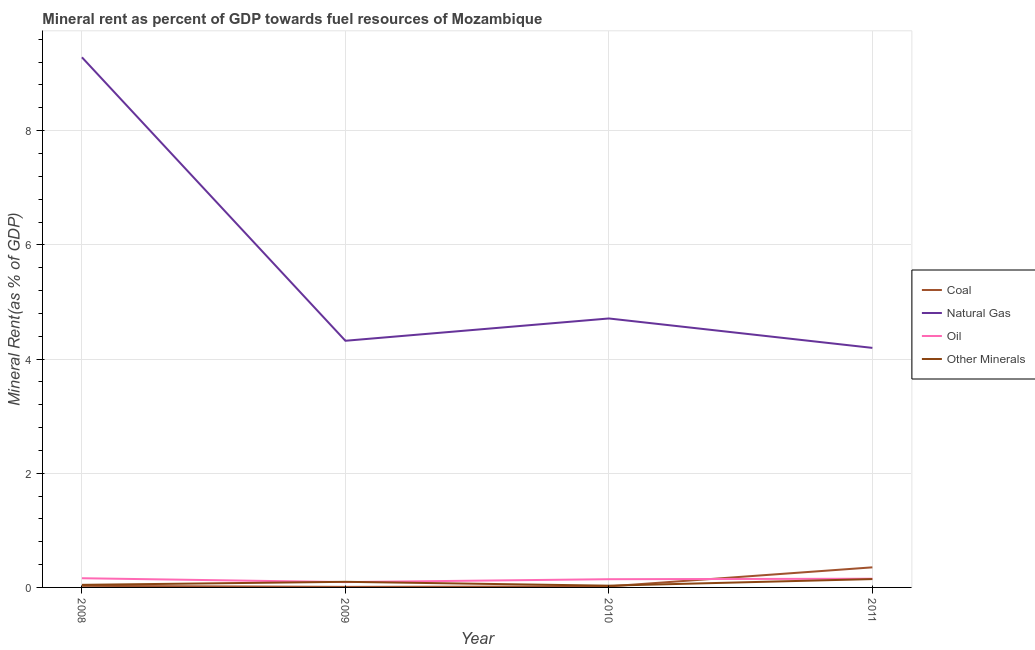Is the number of lines equal to the number of legend labels?
Ensure brevity in your answer.  Yes. What is the natural gas rent in 2011?
Keep it short and to the point. 4.2. Across all years, what is the maximum coal rent?
Ensure brevity in your answer.  0.35. Across all years, what is the minimum natural gas rent?
Offer a terse response. 4.2. What is the total coal rent in the graph?
Your answer should be very brief. 0.41. What is the difference between the  rent of other minerals in 2009 and that in 2010?
Make the answer very short. 0.07. What is the difference between the oil rent in 2009 and the natural gas rent in 2010?
Offer a very short reply. -4.62. What is the average oil rent per year?
Offer a terse response. 0.14. In the year 2009, what is the difference between the oil rent and natural gas rent?
Offer a very short reply. -4.23. In how many years, is the natural gas rent greater than 0.4 %?
Offer a terse response. 4. What is the ratio of the coal rent in 2008 to that in 2009?
Make the answer very short. 2.88. Is the difference between the natural gas rent in 2010 and 2011 greater than the difference between the  rent of other minerals in 2010 and 2011?
Provide a succinct answer. Yes. What is the difference between the highest and the second highest oil rent?
Provide a succinct answer. 0.01. What is the difference between the highest and the lowest  rent of other minerals?
Provide a succinct answer. 0.12. Is it the case that in every year, the sum of the natural gas rent and coal rent is greater than the sum of oil rent and  rent of other minerals?
Your answer should be very brief. Yes. Is the coal rent strictly greater than the natural gas rent over the years?
Your answer should be compact. No. Is the oil rent strictly less than the natural gas rent over the years?
Your answer should be compact. Yes. How many lines are there?
Provide a short and direct response. 4. What is the difference between two consecutive major ticks on the Y-axis?
Give a very brief answer. 2. Does the graph contain any zero values?
Provide a short and direct response. No. Where does the legend appear in the graph?
Give a very brief answer. Center right. How many legend labels are there?
Make the answer very short. 4. How are the legend labels stacked?
Your response must be concise. Vertical. What is the title of the graph?
Your answer should be compact. Mineral rent as percent of GDP towards fuel resources of Mozambique. Does "Insurance services" appear as one of the legend labels in the graph?
Keep it short and to the point. No. What is the label or title of the Y-axis?
Offer a terse response. Mineral Rent(as % of GDP). What is the Mineral Rent(as % of GDP) of Coal in 2008?
Ensure brevity in your answer.  0.03. What is the Mineral Rent(as % of GDP) in Natural Gas in 2008?
Keep it short and to the point. 9.29. What is the Mineral Rent(as % of GDP) in Oil in 2008?
Provide a succinct answer. 0.16. What is the Mineral Rent(as % of GDP) in Other Minerals in 2008?
Provide a succinct answer. 0.05. What is the Mineral Rent(as % of GDP) in Coal in 2009?
Ensure brevity in your answer.  0.01. What is the Mineral Rent(as % of GDP) of Natural Gas in 2009?
Offer a terse response. 4.32. What is the Mineral Rent(as % of GDP) of Oil in 2009?
Give a very brief answer. 0.09. What is the Mineral Rent(as % of GDP) in Other Minerals in 2009?
Your answer should be compact. 0.1. What is the Mineral Rent(as % of GDP) in Coal in 2010?
Keep it short and to the point. 0.02. What is the Mineral Rent(as % of GDP) in Natural Gas in 2010?
Offer a very short reply. 4.71. What is the Mineral Rent(as % of GDP) in Oil in 2010?
Ensure brevity in your answer.  0.14. What is the Mineral Rent(as % of GDP) of Other Minerals in 2010?
Provide a short and direct response. 0.03. What is the Mineral Rent(as % of GDP) in Coal in 2011?
Provide a succinct answer. 0.35. What is the Mineral Rent(as % of GDP) of Natural Gas in 2011?
Ensure brevity in your answer.  4.2. What is the Mineral Rent(as % of GDP) of Oil in 2011?
Your answer should be very brief. 0.15. What is the Mineral Rent(as % of GDP) of Other Minerals in 2011?
Give a very brief answer. 0.15. Across all years, what is the maximum Mineral Rent(as % of GDP) in Coal?
Provide a short and direct response. 0.35. Across all years, what is the maximum Mineral Rent(as % of GDP) of Natural Gas?
Your response must be concise. 9.29. Across all years, what is the maximum Mineral Rent(as % of GDP) in Oil?
Make the answer very short. 0.16. Across all years, what is the maximum Mineral Rent(as % of GDP) in Other Minerals?
Make the answer very short. 0.15. Across all years, what is the minimum Mineral Rent(as % of GDP) of Coal?
Offer a terse response. 0.01. Across all years, what is the minimum Mineral Rent(as % of GDP) in Natural Gas?
Give a very brief answer. 4.2. Across all years, what is the minimum Mineral Rent(as % of GDP) of Oil?
Provide a succinct answer. 0.09. Across all years, what is the minimum Mineral Rent(as % of GDP) of Other Minerals?
Offer a very short reply. 0.03. What is the total Mineral Rent(as % of GDP) of Coal in the graph?
Offer a very short reply. 0.41. What is the total Mineral Rent(as % of GDP) in Natural Gas in the graph?
Offer a very short reply. 22.51. What is the total Mineral Rent(as % of GDP) of Oil in the graph?
Your response must be concise. 0.55. What is the total Mineral Rent(as % of GDP) of Other Minerals in the graph?
Provide a short and direct response. 0.32. What is the difference between the Mineral Rent(as % of GDP) in Coal in 2008 and that in 2009?
Your answer should be very brief. 0.02. What is the difference between the Mineral Rent(as % of GDP) in Natural Gas in 2008 and that in 2009?
Provide a succinct answer. 4.96. What is the difference between the Mineral Rent(as % of GDP) of Oil in 2008 and that in 2009?
Provide a succinct answer. 0.07. What is the difference between the Mineral Rent(as % of GDP) of Other Minerals in 2008 and that in 2009?
Offer a terse response. -0.05. What is the difference between the Mineral Rent(as % of GDP) of Coal in 2008 and that in 2010?
Make the answer very short. 0.01. What is the difference between the Mineral Rent(as % of GDP) of Natural Gas in 2008 and that in 2010?
Your answer should be very brief. 4.57. What is the difference between the Mineral Rent(as % of GDP) in Oil in 2008 and that in 2010?
Your answer should be very brief. 0.02. What is the difference between the Mineral Rent(as % of GDP) in Other Minerals in 2008 and that in 2010?
Offer a very short reply. 0.01. What is the difference between the Mineral Rent(as % of GDP) of Coal in 2008 and that in 2011?
Your response must be concise. -0.32. What is the difference between the Mineral Rent(as % of GDP) in Natural Gas in 2008 and that in 2011?
Offer a terse response. 5.09. What is the difference between the Mineral Rent(as % of GDP) in Oil in 2008 and that in 2011?
Your answer should be compact. 0.01. What is the difference between the Mineral Rent(as % of GDP) of Other Minerals in 2008 and that in 2011?
Make the answer very short. -0.1. What is the difference between the Mineral Rent(as % of GDP) of Coal in 2009 and that in 2010?
Your answer should be compact. -0.01. What is the difference between the Mineral Rent(as % of GDP) in Natural Gas in 2009 and that in 2010?
Give a very brief answer. -0.39. What is the difference between the Mineral Rent(as % of GDP) of Oil in 2009 and that in 2010?
Offer a very short reply. -0.05. What is the difference between the Mineral Rent(as % of GDP) in Other Minerals in 2009 and that in 2010?
Offer a very short reply. 0.07. What is the difference between the Mineral Rent(as % of GDP) in Coal in 2009 and that in 2011?
Your answer should be very brief. -0.34. What is the difference between the Mineral Rent(as % of GDP) of Natural Gas in 2009 and that in 2011?
Give a very brief answer. 0.12. What is the difference between the Mineral Rent(as % of GDP) in Oil in 2009 and that in 2011?
Give a very brief answer. -0.06. What is the difference between the Mineral Rent(as % of GDP) of Other Minerals in 2009 and that in 2011?
Your answer should be very brief. -0.05. What is the difference between the Mineral Rent(as % of GDP) of Coal in 2010 and that in 2011?
Give a very brief answer. -0.33. What is the difference between the Mineral Rent(as % of GDP) of Natural Gas in 2010 and that in 2011?
Your answer should be very brief. 0.52. What is the difference between the Mineral Rent(as % of GDP) in Oil in 2010 and that in 2011?
Your answer should be very brief. -0.01. What is the difference between the Mineral Rent(as % of GDP) of Other Minerals in 2010 and that in 2011?
Make the answer very short. -0.12. What is the difference between the Mineral Rent(as % of GDP) in Coal in 2008 and the Mineral Rent(as % of GDP) in Natural Gas in 2009?
Offer a very short reply. -4.29. What is the difference between the Mineral Rent(as % of GDP) in Coal in 2008 and the Mineral Rent(as % of GDP) in Oil in 2009?
Your answer should be compact. -0.07. What is the difference between the Mineral Rent(as % of GDP) of Coal in 2008 and the Mineral Rent(as % of GDP) of Other Minerals in 2009?
Your response must be concise. -0.07. What is the difference between the Mineral Rent(as % of GDP) in Natural Gas in 2008 and the Mineral Rent(as % of GDP) in Oil in 2009?
Provide a short and direct response. 9.19. What is the difference between the Mineral Rent(as % of GDP) of Natural Gas in 2008 and the Mineral Rent(as % of GDP) of Other Minerals in 2009?
Your response must be concise. 9.19. What is the difference between the Mineral Rent(as % of GDP) of Oil in 2008 and the Mineral Rent(as % of GDP) of Other Minerals in 2009?
Offer a terse response. 0.06. What is the difference between the Mineral Rent(as % of GDP) of Coal in 2008 and the Mineral Rent(as % of GDP) of Natural Gas in 2010?
Provide a succinct answer. -4.68. What is the difference between the Mineral Rent(as % of GDP) in Coal in 2008 and the Mineral Rent(as % of GDP) in Oil in 2010?
Your answer should be compact. -0.12. What is the difference between the Mineral Rent(as % of GDP) in Coal in 2008 and the Mineral Rent(as % of GDP) in Other Minerals in 2010?
Your response must be concise. -0. What is the difference between the Mineral Rent(as % of GDP) in Natural Gas in 2008 and the Mineral Rent(as % of GDP) in Oil in 2010?
Keep it short and to the point. 9.14. What is the difference between the Mineral Rent(as % of GDP) in Natural Gas in 2008 and the Mineral Rent(as % of GDP) in Other Minerals in 2010?
Your response must be concise. 9.25. What is the difference between the Mineral Rent(as % of GDP) of Oil in 2008 and the Mineral Rent(as % of GDP) of Other Minerals in 2010?
Offer a terse response. 0.13. What is the difference between the Mineral Rent(as % of GDP) of Coal in 2008 and the Mineral Rent(as % of GDP) of Natural Gas in 2011?
Make the answer very short. -4.17. What is the difference between the Mineral Rent(as % of GDP) of Coal in 2008 and the Mineral Rent(as % of GDP) of Oil in 2011?
Offer a very short reply. -0.12. What is the difference between the Mineral Rent(as % of GDP) of Coal in 2008 and the Mineral Rent(as % of GDP) of Other Minerals in 2011?
Offer a terse response. -0.12. What is the difference between the Mineral Rent(as % of GDP) of Natural Gas in 2008 and the Mineral Rent(as % of GDP) of Oil in 2011?
Your response must be concise. 9.13. What is the difference between the Mineral Rent(as % of GDP) of Natural Gas in 2008 and the Mineral Rent(as % of GDP) of Other Minerals in 2011?
Give a very brief answer. 9.14. What is the difference between the Mineral Rent(as % of GDP) in Oil in 2008 and the Mineral Rent(as % of GDP) in Other Minerals in 2011?
Give a very brief answer. 0.01. What is the difference between the Mineral Rent(as % of GDP) of Coal in 2009 and the Mineral Rent(as % of GDP) of Natural Gas in 2010?
Your response must be concise. -4.7. What is the difference between the Mineral Rent(as % of GDP) of Coal in 2009 and the Mineral Rent(as % of GDP) of Oil in 2010?
Your response must be concise. -0.13. What is the difference between the Mineral Rent(as % of GDP) in Coal in 2009 and the Mineral Rent(as % of GDP) in Other Minerals in 2010?
Ensure brevity in your answer.  -0.02. What is the difference between the Mineral Rent(as % of GDP) of Natural Gas in 2009 and the Mineral Rent(as % of GDP) of Oil in 2010?
Your response must be concise. 4.18. What is the difference between the Mineral Rent(as % of GDP) in Natural Gas in 2009 and the Mineral Rent(as % of GDP) in Other Minerals in 2010?
Give a very brief answer. 4.29. What is the difference between the Mineral Rent(as % of GDP) of Oil in 2009 and the Mineral Rent(as % of GDP) of Other Minerals in 2010?
Ensure brevity in your answer.  0.06. What is the difference between the Mineral Rent(as % of GDP) of Coal in 2009 and the Mineral Rent(as % of GDP) of Natural Gas in 2011?
Your answer should be compact. -4.19. What is the difference between the Mineral Rent(as % of GDP) of Coal in 2009 and the Mineral Rent(as % of GDP) of Oil in 2011?
Offer a terse response. -0.14. What is the difference between the Mineral Rent(as % of GDP) in Coal in 2009 and the Mineral Rent(as % of GDP) in Other Minerals in 2011?
Your answer should be compact. -0.14. What is the difference between the Mineral Rent(as % of GDP) of Natural Gas in 2009 and the Mineral Rent(as % of GDP) of Oil in 2011?
Ensure brevity in your answer.  4.17. What is the difference between the Mineral Rent(as % of GDP) of Natural Gas in 2009 and the Mineral Rent(as % of GDP) of Other Minerals in 2011?
Offer a very short reply. 4.17. What is the difference between the Mineral Rent(as % of GDP) in Oil in 2009 and the Mineral Rent(as % of GDP) in Other Minerals in 2011?
Your answer should be compact. -0.05. What is the difference between the Mineral Rent(as % of GDP) of Coal in 2010 and the Mineral Rent(as % of GDP) of Natural Gas in 2011?
Provide a succinct answer. -4.18. What is the difference between the Mineral Rent(as % of GDP) of Coal in 2010 and the Mineral Rent(as % of GDP) of Oil in 2011?
Provide a short and direct response. -0.13. What is the difference between the Mineral Rent(as % of GDP) of Coal in 2010 and the Mineral Rent(as % of GDP) of Other Minerals in 2011?
Offer a very short reply. -0.13. What is the difference between the Mineral Rent(as % of GDP) in Natural Gas in 2010 and the Mineral Rent(as % of GDP) in Oil in 2011?
Offer a terse response. 4.56. What is the difference between the Mineral Rent(as % of GDP) in Natural Gas in 2010 and the Mineral Rent(as % of GDP) in Other Minerals in 2011?
Provide a succinct answer. 4.56. What is the difference between the Mineral Rent(as % of GDP) in Oil in 2010 and the Mineral Rent(as % of GDP) in Other Minerals in 2011?
Your answer should be very brief. -0. What is the average Mineral Rent(as % of GDP) of Coal per year?
Provide a short and direct response. 0.1. What is the average Mineral Rent(as % of GDP) of Natural Gas per year?
Ensure brevity in your answer.  5.63. What is the average Mineral Rent(as % of GDP) in Oil per year?
Offer a very short reply. 0.14. What is the average Mineral Rent(as % of GDP) of Other Minerals per year?
Provide a short and direct response. 0.08. In the year 2008, what is the difference between the Mineral Rent(as % of GDP) in Coal and Mineral Rent(as % of GDP) in Natural Gas?
Provide a short and direct response. -9.26. In the year 2008, what is the difference between the Mineral Rent(as % of GDP) of Coal and Mineral Rent(as % of GDP) of Oil?
Your answer should be very brief. -0.13. In the year 2008, what is the difference between the Mineral Rent(as % of GDP) in Coal and Mineral Rent(as % of GDP) in Other Minerals?
Your answer should be compact. -0.02. In the year 2008, what is the difference between the Mineral Rent(as % of GDP) in Natural Gas and Mineral Rent(as % of GDP) in Oil?
Offer a very short reply. 9.12. In the year 2008, what is the difference between the Mineral Rent(as % of GDP) of Natural Gas and Mineral Rent(as % of GDP) of Other Minerals?
Ensure brevity in your answer.  9.24. In the year 2008, what is the difference between the Mineral Rent(as % of GDP) in Oil and Mineral Rent(as % of GDP) in Other Minerals?
Keep it short and to the point. 0.12. In the year 2009, what is the difference between the Mineral Rent(as % of GDP) of Coal and Mineral Rent(as % of GDP) of Natural Gas?
Give a very brief answer. -4.31. In the year 2009, what is the difference between the Mineral Rent(as % of GDP) in Coal and Mineral Rent(as % of GDP) in Oil?
Make the answer very short. -0.08. In the year 2009, what is the difference between the Mineral Rent(as % of GDP) of Coal and Mineral Rent(as % of GDP) of Other Minerals?
Your answer should be very brief. -0.09. In the year 2009, what is the difference between the Mineral Rent(as % of GDP) of Natural Gas and Mineral Rent(as % of GDP) of Oil?
Your answer should be compact. 4.23. In the year 2009, what is the difference between the Mineral Rent(as % of GDP) in Natural Gas and Mineral Rent(as % of GDP) in Other Minerals?
Your response must be concise. 4.22. In the year 2009, what is the difference between the Mineral Rent(as % of GDP) of Oil and Mineral Rent(as % of GDP) of Other Minerals?
Give a very brief answer. -0.01. In the year 2010, what is the difference between the Mineral Rent(as % of GDP) in Coal and Mineral Rent(as % of GDP) in Natural Gas?
Give a very brief answer. -4.69. In the year 2010, what is the difference between the Mineral Rent(as % of GDP) of Coal and Mineral Rent(as % of GDP) of Oil?
Your response must be concise. -0.13. In the year 2010, what is the difference between the Mineral Rent(as % of GDP) in Coal and Mineral Rent(as % of GDP) in Other Minerals?
Give a very brief answer. -0.01. In the year 2010, what is the difference between the Mineral Rent(as % of GDP) of Natural Gas and Mineral Rent(as % of GDP) of Oil?
Offer a terse response. 4.57. In the year 2010, what is the difference between the Mineral Rent(as % of GDP) of Natural Gas and Mineral Rent(as % of GDP) of Other Minerals?
Your answer should be compact. 4.68. In the year 2010, what is the difference between the Mineral Rent(as % of GDP) in Oil and Mineral Rent(as % of GDP) in Other Minerals?
Offer a very short reply. 0.11. In the year 2011, what is the difference between the Mineral Rent(as % of GDP) of Coal and Mineral Rent(as % of GDP) of Natural Gas?
Offer a very short reply. -3.84. In the year 2011, what is the difference between the Mineral Rent(as % of GDP) in Coal and Mineral Rent(as % of GDP) in Oil?
Make the answer very short. 0.2. In the year 2011, what is the difference between the Mineral Rent(as % of GDP) of Coal and Mineral Rent(as % of GDP) of Other Minerals?
Your answer should be compact. 0.21. In the year 2011, what is the difference between the Mineral Rent(as % of GDP) in Natural Gas and Mineral Rent(as % of GDP) in Oil?
Provide a short and direct response. 4.04. In the year 2011, what is the difference between the Mineral Rent(as % of GDP) in Natural Gas and Mineral Rent(as % of GDP) in Other Minerals?
Make the answer very short. 4.05. In the year 2011, what is the difference between the Mineral Rent(as % of GDP) in Oil and Mineral Rent(as % of GDP) in Other Minerals?
Make the answer very short. 0.01. What is the ratio of the Mineral Rent(as % of GDP) in Coal in 2008 to that in 2009?
Offer a very short reply. 2.88. What is the ratio of the Mineral Rent(as % of GDP) in Natural Gas in 2008 to that in 2009?
Provide a short and direct response. 2.15. What is the ratio of the Mineral Rent(as % of GDP) in Oil in 2008 to that in 2009?
Your response must be concise. 1.73. What is the ratio of the Mineral Rent(as % of GDP) of Other Minerals in 2008 to that in 2009?
Keep it short and to the point. 0.46. What is the ratio of the Mineral Rent(as % of GDP) in Coal in 2008 to that in 2010?
Your answer should be very brief. 1.5. What is the ratio of the Mineral Rent(as % of GDP) of Natural Gas in 2008 to that in 2010?
Your response must be concise. 1.97. What is the ratio of the Mineral Rent(as % of GDP) of Oil in 2008 to that in 2010?
Make the answer very short. 1.12. What is the ratio of the Mineral Rent(as % of GDP) in Other Minerals in 2008 to that in 2010?
Provide a succinct answer. 1.48. What is the ratio of the Mineral Rent(as % of GDP) of Coal in 2008 to that in 2011?
Give a very brief answer. 0.08. What is the ratio of the Mineral Rent(as % of GDP) in Natural Gas in 2008 to that in 2011?
Offer a terse response. 2.21. What is the ratio of the Mineral Rent(as % of GDP) in Oil in 2008 to that in 2011?
Give a very brief answer. 1.06. What is the ratio of the Mineral Rent(as % of GDP) of Other Minerals in 2008 to that in 2011?
Offer a terse response. 0.31. What is the ratio of the Mineral Rent(as % of GDP) of Coal in 2009 to that in 2010?
Provide a succinct answer. 0.52. What is the ratio of the Mineral Rent(as % of GDP) of Natural Gas in 2009 to that in 2010?
Provide a succinct answer. 0.92. What is the ratio of the Mineral Rent(as % of GDP) of Oil in 2009 to that in 2010?
Offer a very short reply. 0.65. What is the ratio of the Mineral Rent(as % of GDP) of Other Minerals in 2009 to that in 2010?
Ensure brevity in your answer.  3.23. What is the ratio of the Mineral Rent(as % of GDP) of Coal in 2009 to that in 2011?
Provide a succinct answer. 0.03. What is the ratio of the Mineral Rent(as % of GDP) of Natural Gas in 2009 to that in 2011?
Your response must be concise. 1.03. What is the ratio of the Mineral Rent(as % of GDP) in Oil in 2009 to that in 2011?
Give a very brief answer. 0.61. What is the ratio of the Mineral Rent(as % of GDP) of Other Minerals in 2009 to that in 2011?
Offer a terse response. 0.67. What is the ratio of the Mineral Rent(as % of GDP) of Coal in 2010 to that in 2011?
Make the answer very short. 0.05. What is the ratio of the Mineral Rent(as % of GDP) of Natural Gas in 2010 to that in 2011?
Offer a very short reply. 1.12. What is the ratio of the Mineral Rent(as % of GDP) in Oil in 2010 to that in 2011?
Your response must be concise. 0.94. What is the ratio of the Mineral Rent(as % of GDP) in Other Minerals in 2010 to that in 2011?
Your response must be concise. 0.21. What is the difference between the highest and the second highest Mineral Rent(as % of GDP) of Coal?
Offer a very short reply. 0.32. What is the difference between the highest and the second highest Mineral Rent(as % of GDP) in Natural Gas?
Your answer should be compact. 4.57. What is the difference between the highest and the second highest Mineral Rent(as % of GDP) of Oil?
Your response must be concise. 0.01. What is the difference between the highest and the second highest Mineral Rent(as % of GDP) of Other Minerals?
Give a very brief answer. 0.05. What is the difference between the highest and the lowest Mineral Rent(as % of GDP) of Coal?
Offer a terse response. 0.34. What is the difference between the highest and the lowest Mineral Rent(as % of GDP) in Natural Gas?
Keep it short and to the point. 5.09. What is the difference between the highest and the lowest Mineral Rent(as % of GDP) in Oil?
Provide a short and direct response. 0.07. What is the difference between the highest and the lowest Mineral Rent(as % of GDP) in Other Minerals?
Provide a succinct answer. 0.12. 